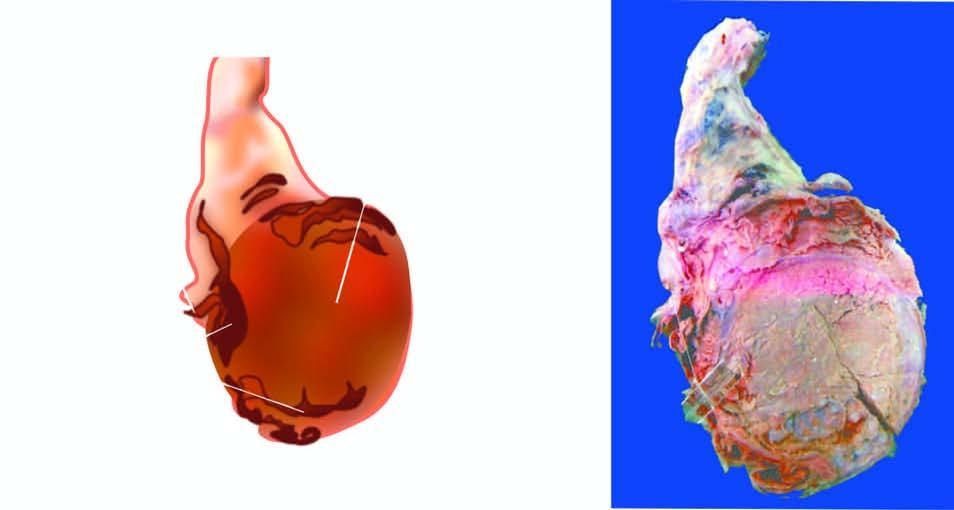does peripheral blood in itp show replacement of the entire testis by variegated mass having grey-white solid areas, cystic areas, honey-combed areas and foci of cartilage and bone?
Answer the question using a single word or phrase. No 